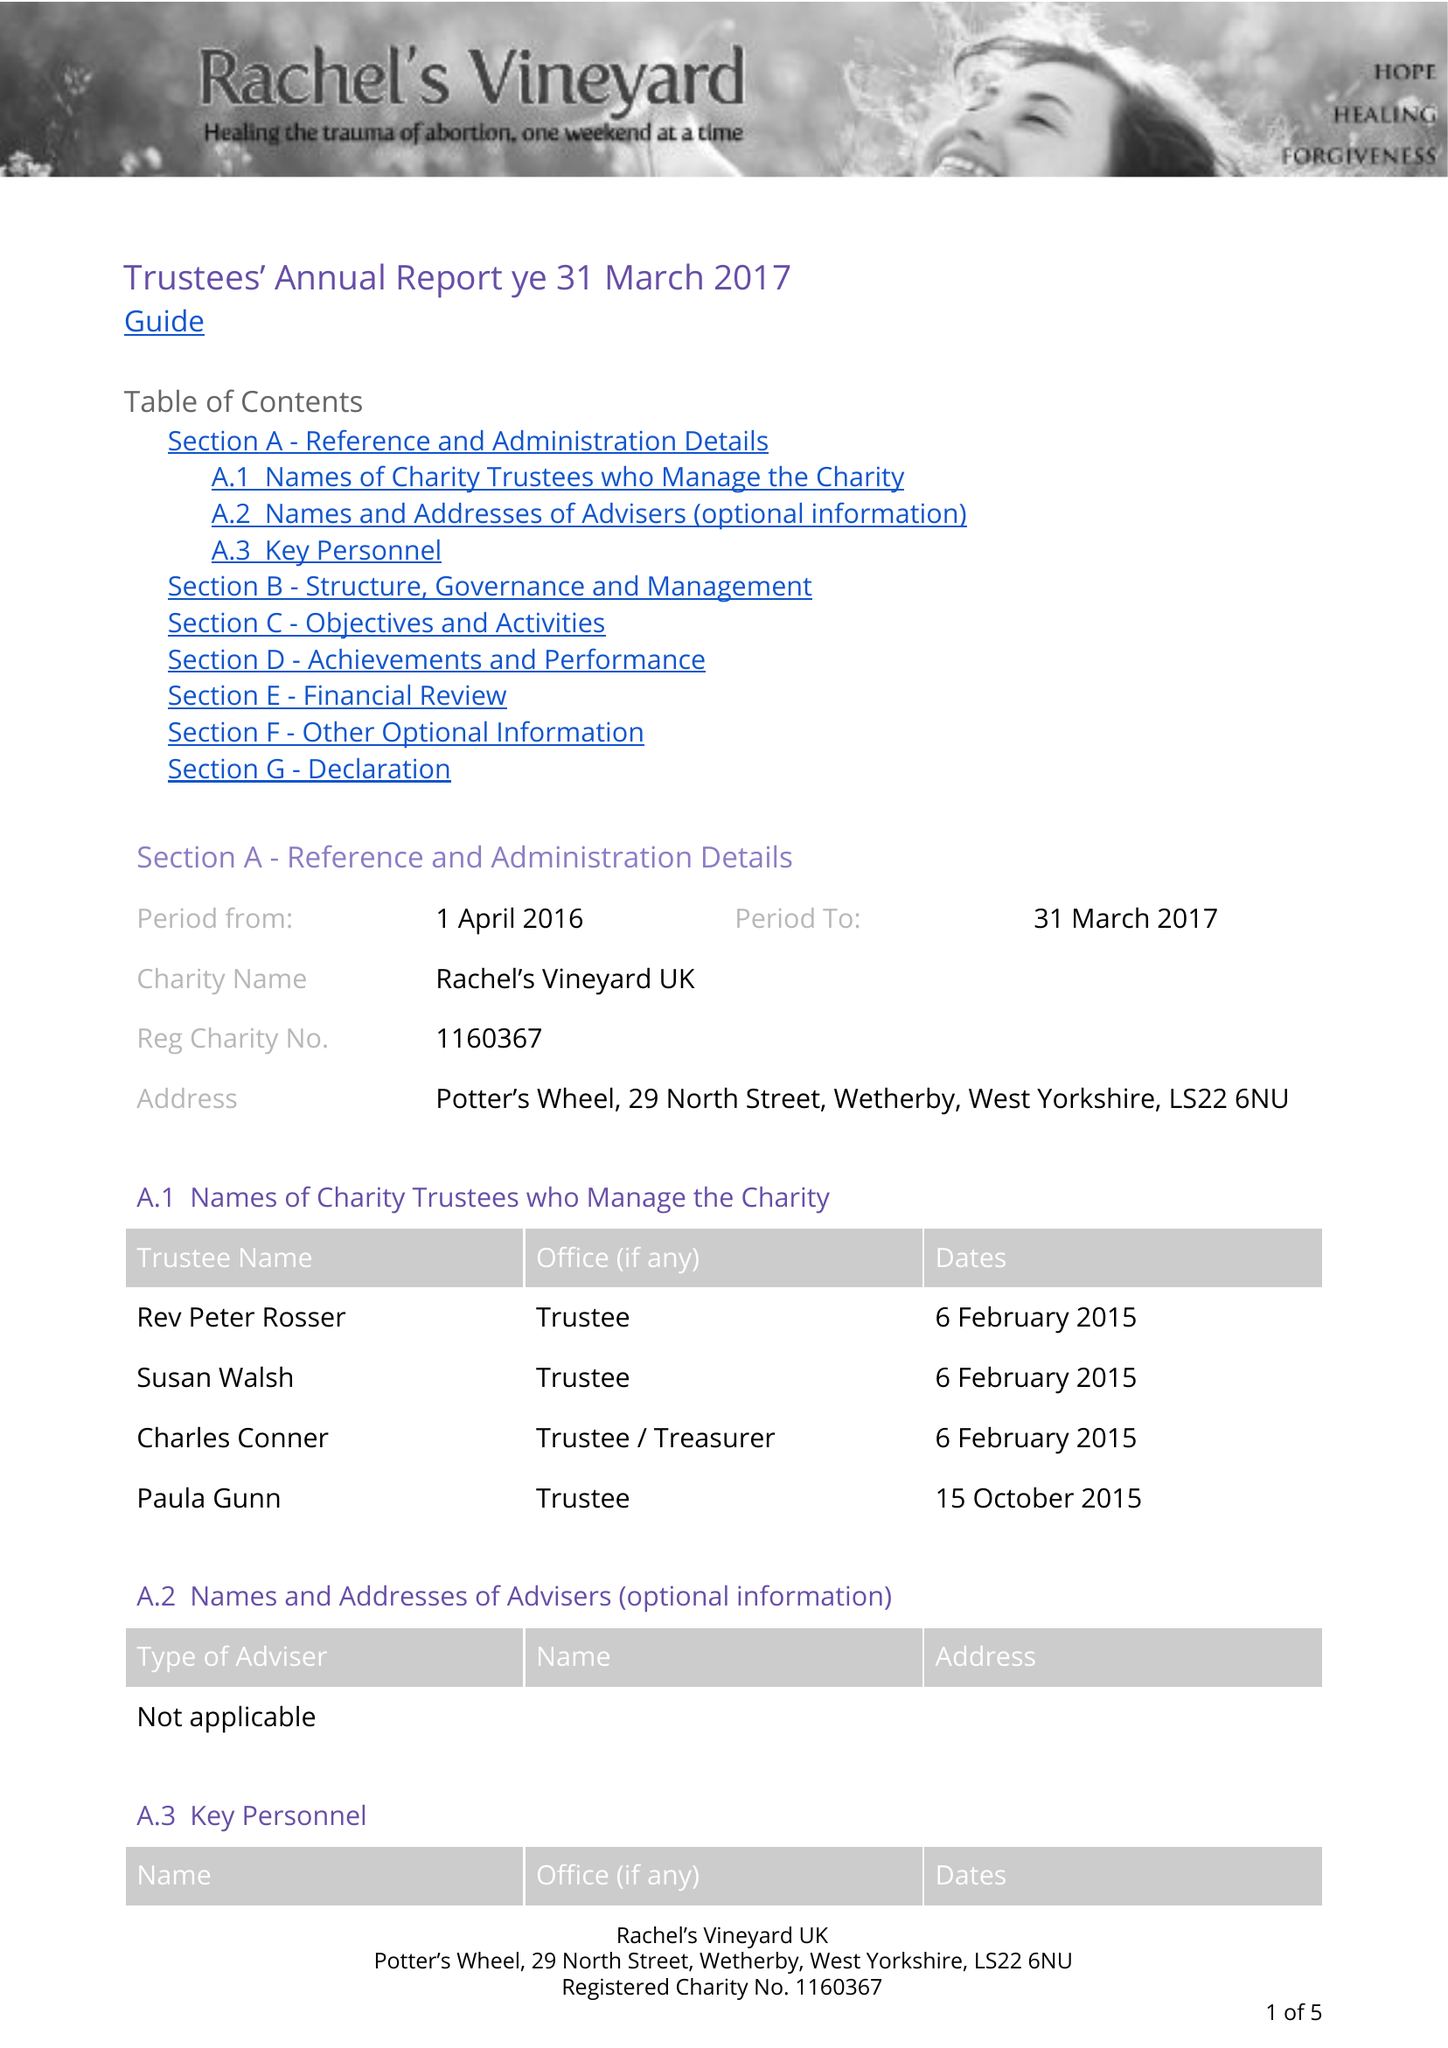What is the value for the charity_name?
Answer the question using a single word or phrase. Rachel's Vineyard Uk 